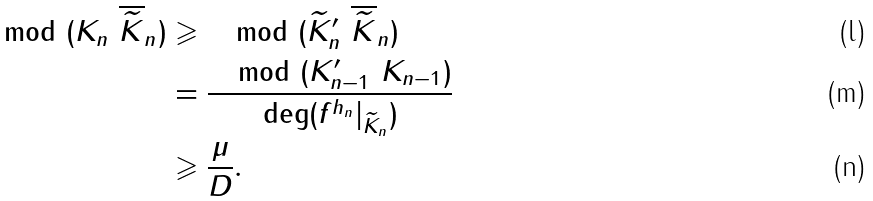Convert formula to latex. <formula><loc_0><loc_0><loc_500><loc_500>\mod ( K _ { n } \ \overline { \widetilde { K } } _ { n } ) & \geqslant \mod ( \widetilde { K } _ { n } ^ { \prime } \ \overline { \widetilde { K } } _ { n } ) \\ & = \frac { \mod ( K ^ { \prime } _ { n - 1 } \ K _ { n - 1 } ) } { \deg ( f ^ { h _ { n } } | _ { \widetilde { K } _ { n } } ) } \\ & \geqslant \frac { \mu } { D } .</formula> 